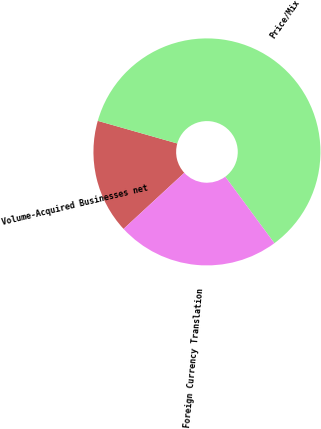Convert chart to OTSL. <chart><loc_0><loc_0><loc_500><loc_500><pie_chart><fcel>Volume-Acquired Businesses net<fcel>Price/Mix<fcel>Foreign Currency Translation<nl><fcel>16.28%<fcel>60.47%<fcel>23.26%<nl></chart> 